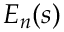<formula> <loc_0><loc_0><loc_500><loc_500>E _ { n } ( s )</formula> 